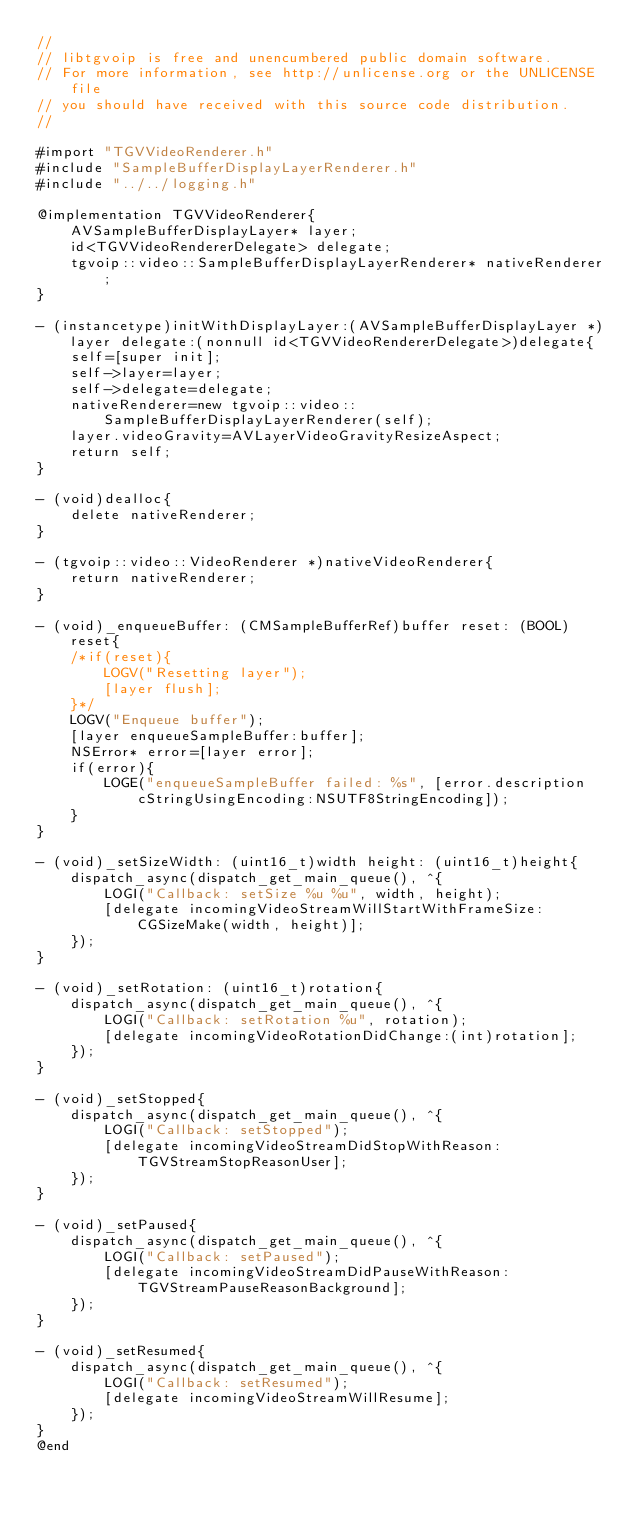Convert code to text. <code><loc_0><loc_0><loc_500><loc_500><_ObjectiveC_>//
// libtgvoip is free and unencumbered public domain software.
// For more information, see http://unlicense.org or the UNLICENSE file
// you should have received with this source code distribution.
//

#import "TGVVideoRenderer.h"
#include "SampleBufferDisplayLayerRenderer.h"
#include "../../logging.h"

@implementation TGVVideoRenderer{
	AVSampleBufferDisplayLayer* layer;
	id<TGVVideoRendererDelegate> delegate;
	tgvoip::video::SampleBufferDisplayLayerRenderer* nativeRenderer;
}

- (instancetype)initWithDisplayLayer:(AVSampleBufferDisplayLayer *)layer delegate:(nonnull id<TGVVideoRendererDelegate>)delegate{
	self=[super init];
	self->layer=layer;
	self->delegate=delegate;
	nativeRenderer=new tgvoip::video::SampleBufferDisplayLayerRenderer(self);
	layer.videoGravity=AVLayerVideoGravityResizeAspect;
	return self;
}

- (void)dealloc{
	delete nativeRenderer;
}

- (tgvoip::video::VideoRenderer *)nativeVideoRenderer{
	return nativeRenderer;
}

- (void)_enqueueBuffer: (CMSampleBufferRef)buffer reset: (BOOL)reset{
	/*if(reset){
		LOGV("Resetting layer");
		[layer flush];
	}*/
	LOGV("Enqueue buffer");
    [layer enqueueSampleBuffer:buffer];
    NSError* error=[layer error];
    if(error){
    	LOGE("enqueueSampleBuffer failed: %s", [error.description cStringUsingEncoding:NSUTF8StringEncoding]);
    }
}

- (void)_setSizeWidth: (uint16_t)width height: (uint16_t)height{
	dispatch_async(dispatch_get_main_queue(), ^{
		LOGI("Callback: setSize %u %u", width, height);
		[delegate incomingVideoStreamWillStartWithFrameSize:CGSizeMake(width, height)];
	});
}

- (void)_setRotation: (uint16_t)rotation{
	dispatch_async(dispatch_get_main_queue(), ^{
		LOGI("Callback: setRotation %u", rotation);
		[delegate incomingVideoRotationDidChange:(int)rotation];
	});
}

- (void)_setStopped{
	dispatch_async(dispatch_get_main_queue(), ^{
		LOGI("Callback: setStopped");
		[delegate incomingVideoStreamDidStopWithReason:TGVStreamStopReasonUser];
	});
}

- (void)_setPaused{
	dispatch_async(dispatch_get_main_queue(), ^{
		LOGI("Callback: setPaused");
		[delegate incomingVideoStreamDidPauseWithReason:TGVStreamPauseReasonBackground];
	});
}

- (void)_setResumed{
	dispatch_async(dispatch_get_main_queue(), ^{
		LOGI("Callback: setResumed");
		[delegate incomingVideoStreamWillResume];
	});
}
@end
</code> 